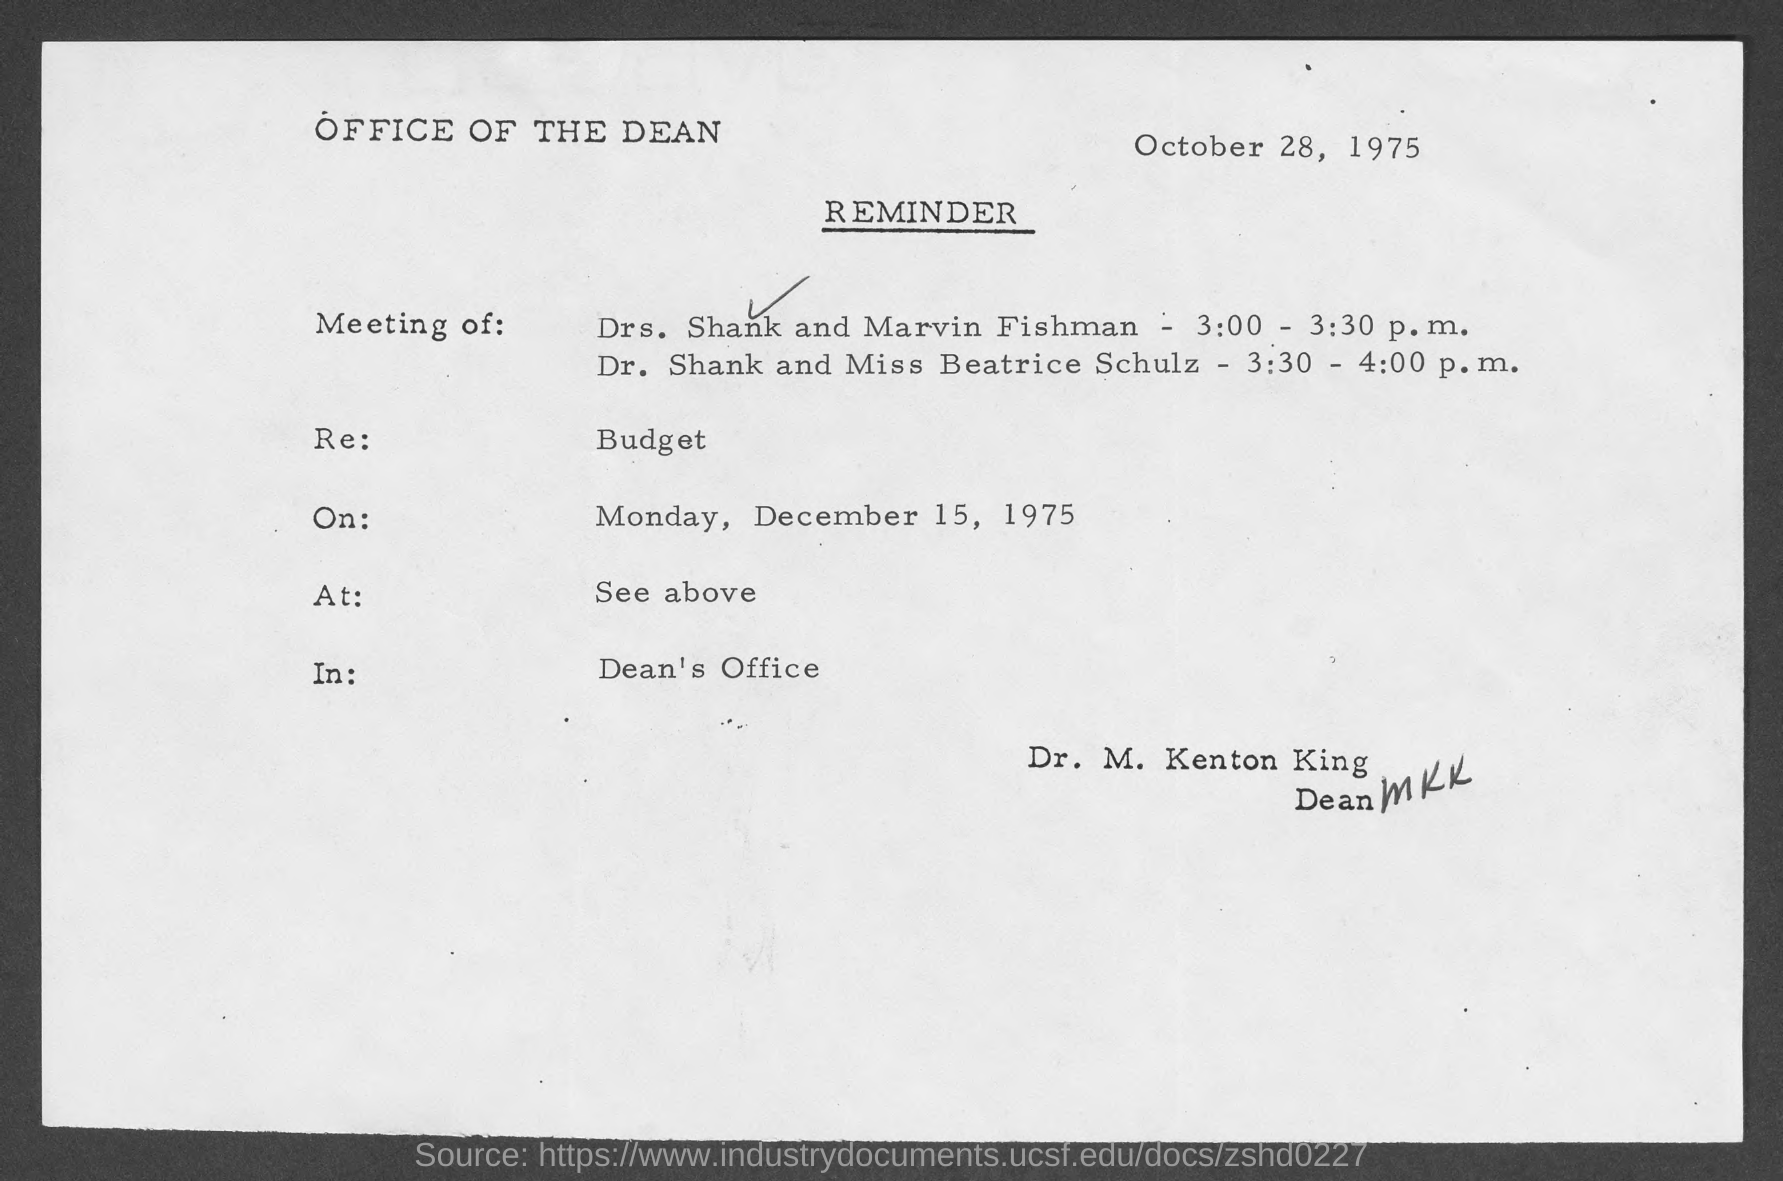When is the reminder dated?
Offer a terse response. OCTOBER 28, 1975. What is re. of the reminder?
Your answer should be compact. Budget. On what date is the meeting scheduled?
Give a very brief answer. December 15, 1975. On what day of the week is the meeting scheduled?
Provide a short and direct response. Monday. What is the venue for meeting ?
Ensure brevity in your answer.  DEAN'S OFFICE. 